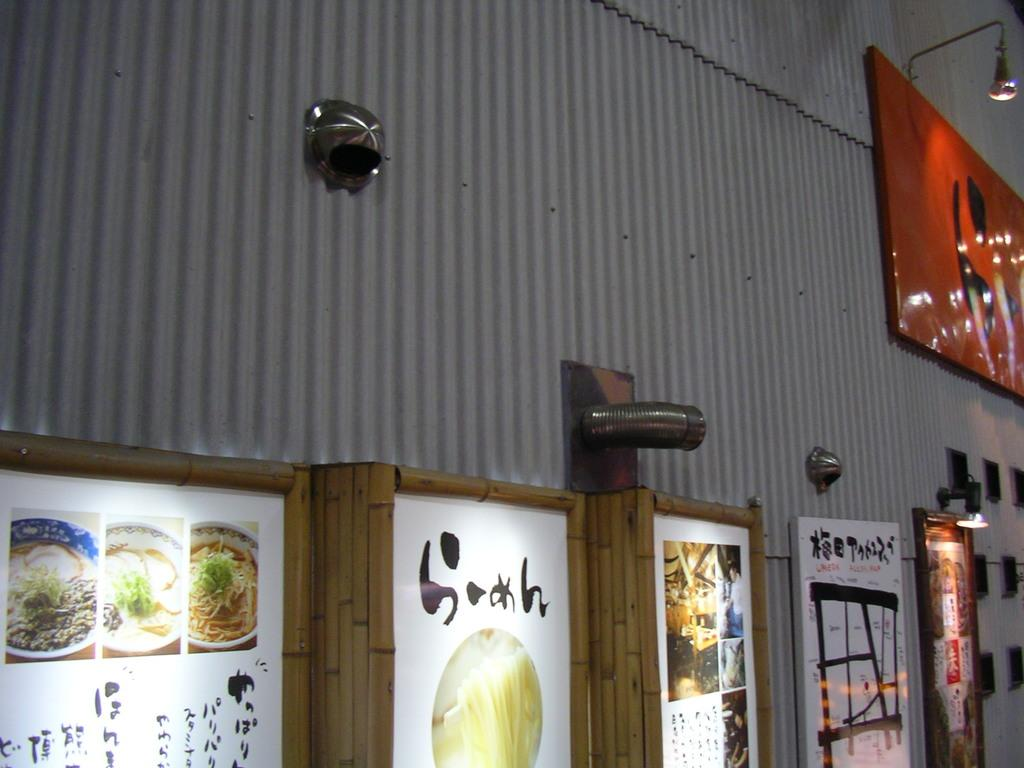What type of objects are made of metal in the image? There are metal objects in the image. What other items can be seen in the image? There are banners, lamps, and frames in the image. How are these objects connected in the image? These objects are associated with a metal sheet. What type of stage is present in the image? There is no stage present in the image. How does the power supply work for the lamps in the image? The image does not provide information about the power supply for the lamps. 